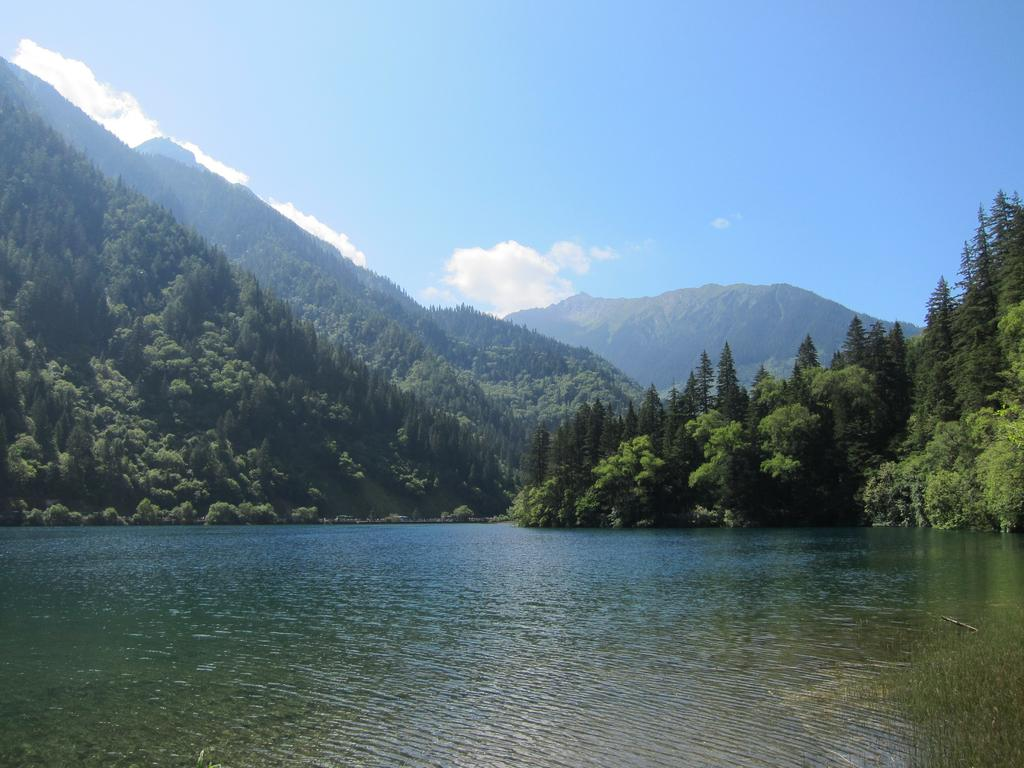What is visible at the bottom of the image? There is water visible at the bottom of the image. What can be seen in the background of the image? There are trees, mountains, and clouds in the sky in the background of the image. What type of honey can be seen dripping from the trees in the image? There is no honey present in the image; it features water, trees, mountains, and clouds. 